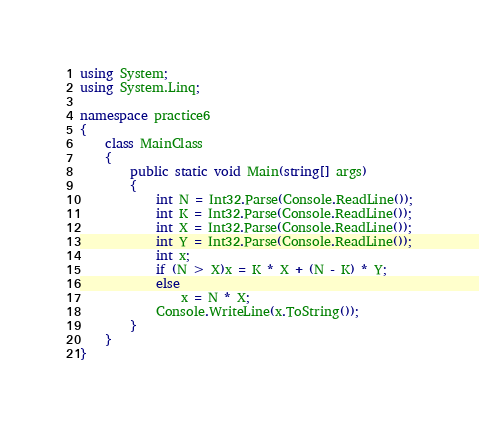Convert code to text. <code><loc_0><loc_0><loc_500><loc_500><_C#_>using System;
using System.Linq;

namespace practice6
{
    class MainClass
    {
        public static void Main(string[] args)
        {
            int N = Int32.Parse(Console.ReadLine());
            int K = Int32.Parse(Console.ReadLine());
            int X = Int32.Parse(Console.ReadLine());
            int Y = Int32.Parse(Console.ReadLine());
            int x;
            if (N > X)x = K * X + (N - K) * Y;
            else
                x = N * X;
            Console.WriteLine(x.ToString());
        }
    }
}</code> 